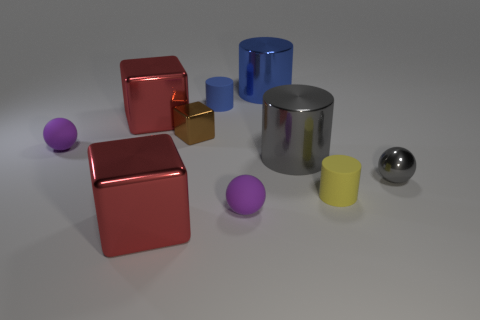Are there any other objects that are the same color as the purple block seen in the image? Yes, in addition to the large purple block, there are two small spheres that share a similar purple hue. The colors are not identical due to variations in material and light absorption, but they clearly belong to the same color family. 